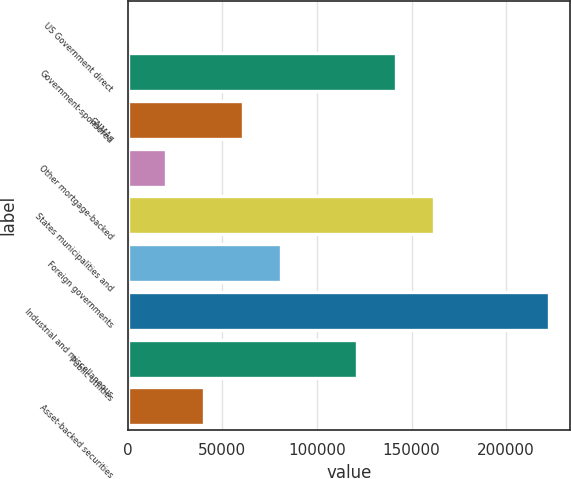<chart> <loc_0><loc_0><loc_500><loc_500><bar_chart><fcel>US Government direct<fcel>Government-sponsored<fcel>GNMAs<fcel>Other mortgage-backed<fcel>States municipalities and<fcel>Foreign governments<fcel>Industrial and miscellaneous<fcel>Public utilities<fcel>Asset-backed securities<nl><fcel>1<fcel>141628<fcel>60698.2<fcel>20233.4<fcel>161860<fcel>80930.6<fcel>222557<fcel>121395<fcel>40465.8<nl></chart> 